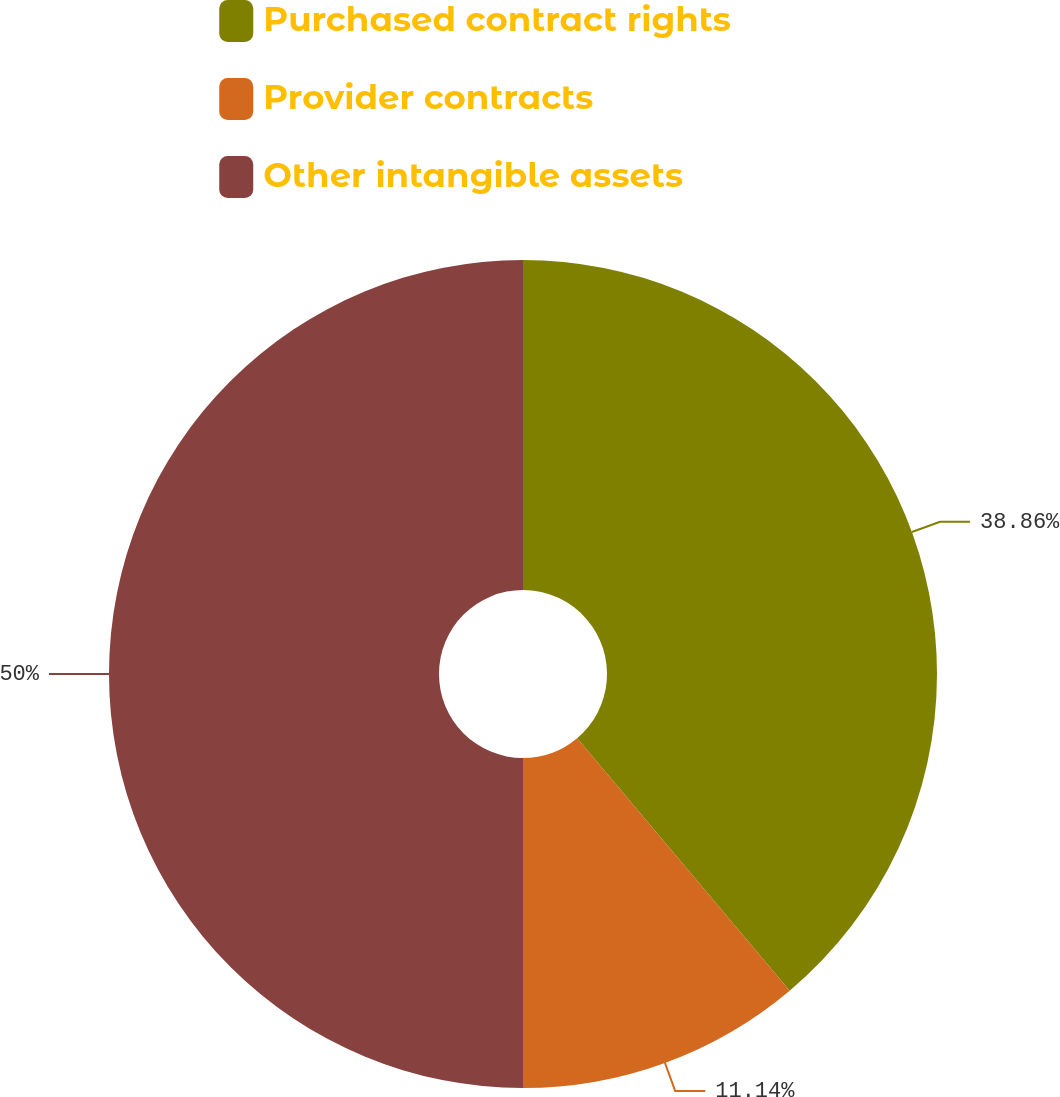Convert chart to OTSL. <chart><loc_0><loc_0><loc_500><loc_500><pie_chart><fcel>Purchased contract rights<fcel>Provider contracts<fcel>Other intangible assets<nl><fcel>38.86%<fcel>11.14%<fcel>50.0%<nl></chart> 